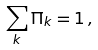Convert formula to latex. <formula><loc_0><loc_0><loc_500><loc_500>\sum _ { k } \Pi _ { k } = 1 \, ,</formula> 